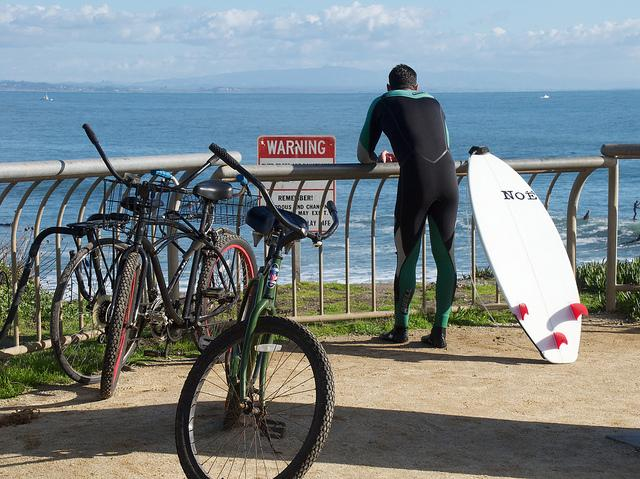What kind of surfboard it is? Please explain your reasoning. short board. The board is miniature sized. 